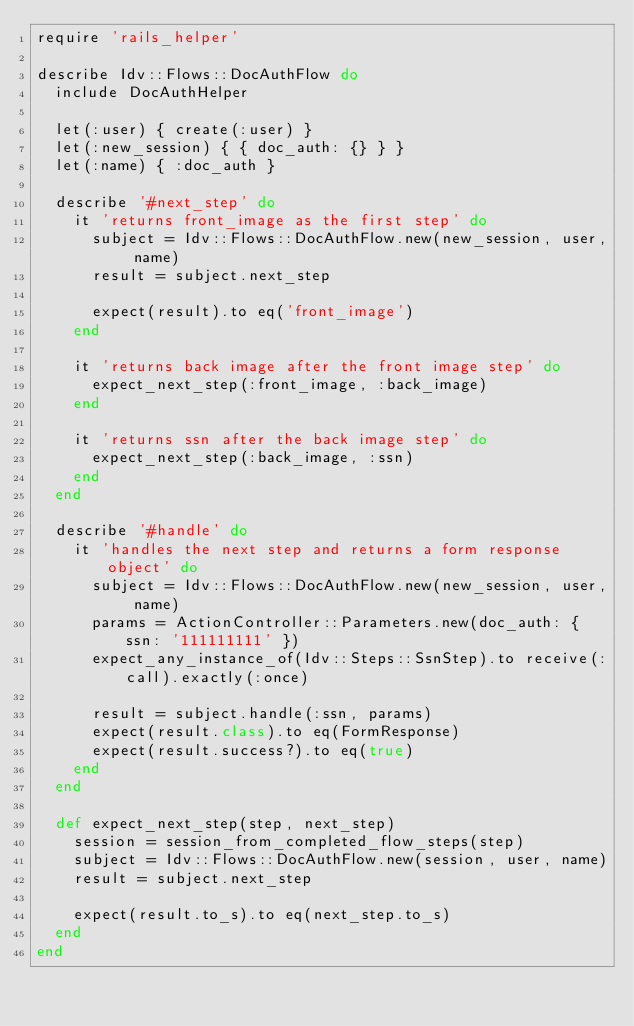Convert code to text. <code><loc_0><loc_0><loc_500><loc_500><_Ruby_>require 'rails_helper'

describe Idv::Flows::DocAuthFlow do
  include DocAuthHelper

  let(:user) { create(:user) }
  let(:new_session) { { doc_auth: {} } }
  let(:name) { :doc_auth }

  describe '#next_step' do
    it 'returns front_image as the first step' do
      subject = Idv::Flows::DocAuthFlow.new(new_session, user, name)
      result = subject.next_step

      expect(result).to eq('front_image')
    end

    it 'returns back image after the front image step' do
      expect_next_step(:front_image, :back_image)
    end

    it 'returns ssn after the back image step' do
      expect_next_step(:back_image, :ssn)
    end
  end

  describe '#handle' do
    it 'handles the next step and returns a form response object' do
      subject = Idv::Flows::DocAuthFlow.new(new_session, user, name)
      params = ActionController::Parameters.new(doc_auth: { ssn: '111111111' })
      expect_any_instance_of(Idv::Steps::SsnStep).to receive(:call).exactly(:once)

      result = subject.handle(:ssn, params)
      expect(result.class).to eq(FormResponse)
      expect(result.success?).to eq(true)
    end
  end

  def expect_next_step(step, next_step)
    session = session_from_completed_flow_steps(step)
    subject = Idv::Flows::DocAuthFlow.new(session, user, name)
    result = subject.next_step

    expect(result.to_s).to eq(next_step.to_s)
  end
end
</code> 